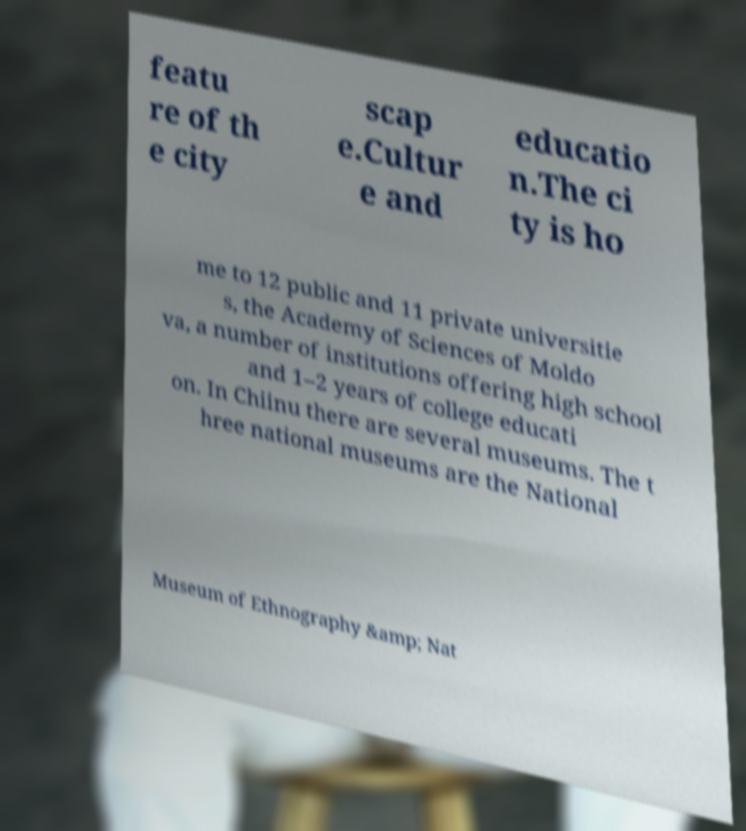Please identify and transcribe the text found in this image. featu re of th e city scap e.Cultur e and educatio n.The ci ty is ho me to 12 public and 11 private universitie s, the Academy of Sciences of Moldo va, a number of institutions offering high school and 1–2 years of college educati on. In Chiinu there are several museums. The t hree national museums are the National Museum of Ethnography &amp; Nat 